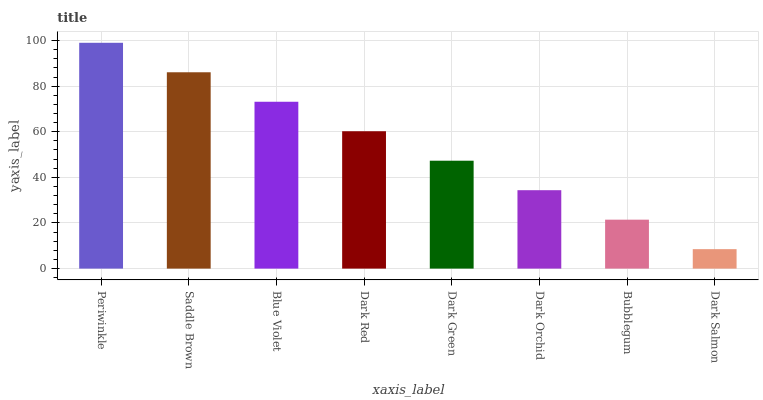Is Dark Salmon the minimum?
Answer yes or no. Yes. Is Periwinkle the maximum?
Answer yes or no. Yes. Is Saddle Brown the minimum?
Answer yes or no. No. Is Saddle Brown the maximum?
Answer yes or no. No. Is Periwinkle greater than Saddle Brown?
Answer yes or no. Yes. Is Saddle Brown less than Periwinkle?
Answer yes or no. Yes. Is Saddle Brown greater than Periwinkle?
Answer yes or no. No. Is Periwinkle less than Saddle Brown?
Answer yes or no. No. Is Dark Red the high median?
Answer yes or no. Yes. Is Dark Green the low median?
Answer yes or no. Yes. Is Saddle Brown the high median?
Answer yes or no. No. Is Dark Salmon the low median?
Answer yes or no. No. 